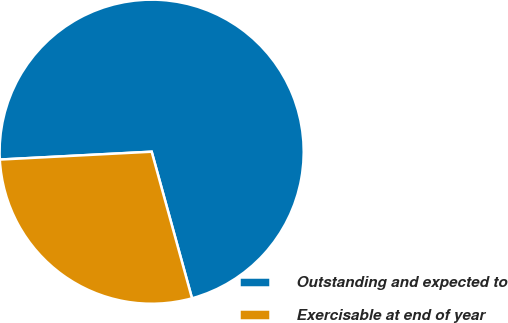<chart> <loc_0><loc_0><loc_500><loc_500><pie_chart><fcel>Outstanding and expected to<fcel>Exercisable at end of year<nl><fcel>71.55%<fcel>28.45%<nl></chart> 